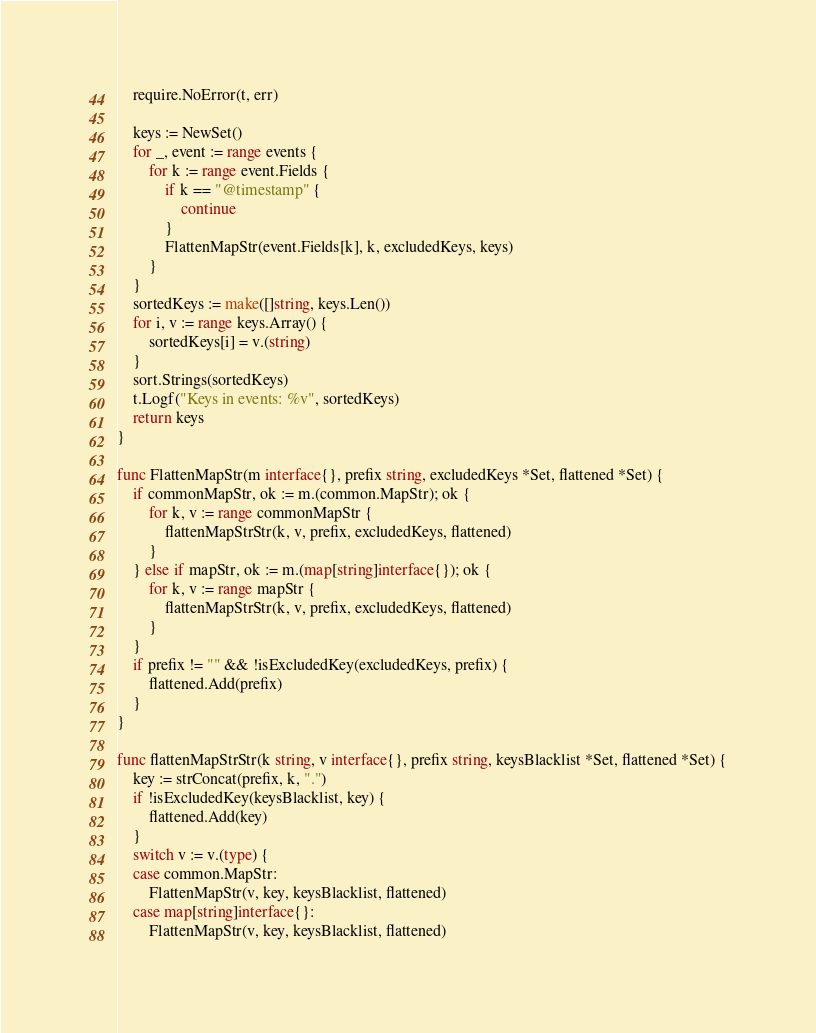<code> <loc_0><loc_0><loc_500><loc_500><_Go_>	require.NoError(t, err)

	keys := NewSet()
	for _, event := range events {
		for k := range event.Fields {
			if k == "@timestamp" {
				continue
			}
			FlattenMapStr(event.Fields[k], k, excludedKeys, keys)
		}
	}
	sortedKeys := make([]string, keys.Len())
	for i, v := range keys.Array() {
		sortedKeys[i] = v.(string)
	}
	sort.Strings(sortedKeys)
	t.Logf("Keys in events: %v", sortedKeys)
	return keys
}

func FlattenMapStr(m interface{}, prefix string, excludedKeys *Set, flattened *Set) {
	if commonMapStr, ok := m.(common.MapStr); ok {
		for k, v := range commonMapStr {
			flattenMapStrStr(k, v, prefix, excludedKeys, flattened)
		}
	} else if mapStr, ok := m.(map[string]interface{}); ok {
		for k, v := range mapStr {
			flattenMapStrStr(k, v, prefix, excludedKeys, flattened)
		}
	}
	if prefix != "" && !isExcludedKey(excludedKeys, prefix) {
		flattened.Add(prefix)
	}
}

func flattenMapStrStr(k string, v interface{}, prefix string, keysBlacklist *Set, flattened *Set) {
	key := strConcat(prefix, k, ".")
	if !isExcludedKey(keysBlacklist, key) {
		flattened.Add(key)
	}
	switch v := v.(type) {
	case common.MapStr:
		FlattenMapStr(v, key, keysBlacklist, flattened)
	case map[string]interface{}:
		FlattenMapStr(v, key, keysBlacklist, flattened)</code> 